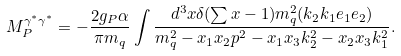Convert formula to latex. <formula><loc_0><loc_0><loc_500><loc_500>M _ { P } ^ { \gamma ^ { * } \gamma ^ { * } } = - \frac { 2 g _ { P } \alpha } { \pi m _ { q } } \int \frac { d ^ { 3 } x \delta ( \sum x - 1 ) m _ { q } ^ { 2 } ( k _ { 2 } k _ { 1 } e _ { 1 } e _ { 2 } ) } { m _ { q } ^ { 2 } - x _ { 1 } x _ { 2 } p ^ { 2 } - x _ { 1 } x _ { 3 } k _ { 2 } ^ { 2 } - x _ { 2 } x _ { 3 } k _ { 1 } ^ { 2 } } .</formula> 